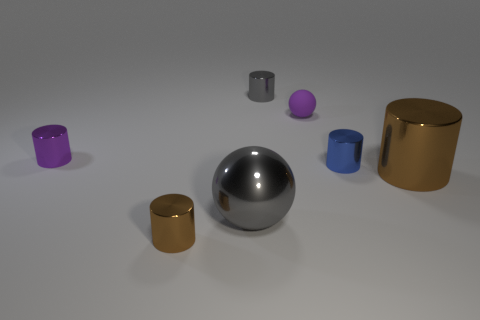There is a tiny thing that is both in front of the purple metal cylinder and right of the small brown cylinder; what is its color?
Your response must be concise. Blue. There is a metal cylinder that is behind the purple cylinder; what size is it?
Ensure brevity in your answer.  Small. What number of large cyan cylinders are made of the same material as the gray cylinder?
Make the answer very short. 0. Does the tiny thing in front of the big gray metallic sphere have the same shape as the large brown object?
Make the answer very short. Yes. What color is the large sphere that is made of the same material as the gray cylinder?
Your answer should be compact. Gray. Are there any purple things that are to the right of the gray metallic object that is behind the small object that is right of the small matte thing?
Keep it short and to the point. Yes. The purple rubber object is what shape?
Offer a very short reply. Sphere. Is the number of shiny objects on the right side of the small blue thing less than the number of small gray metallic things?
Ensure brevity in your answer.  No. Is there a big metallic object of the same shape as the rubber object?
Your response must be concise. Yes. There is a purple rubber thing that is the same size as the gray cylinder; what shape is it?
Ensure brevity in your answer.  Sphere. 